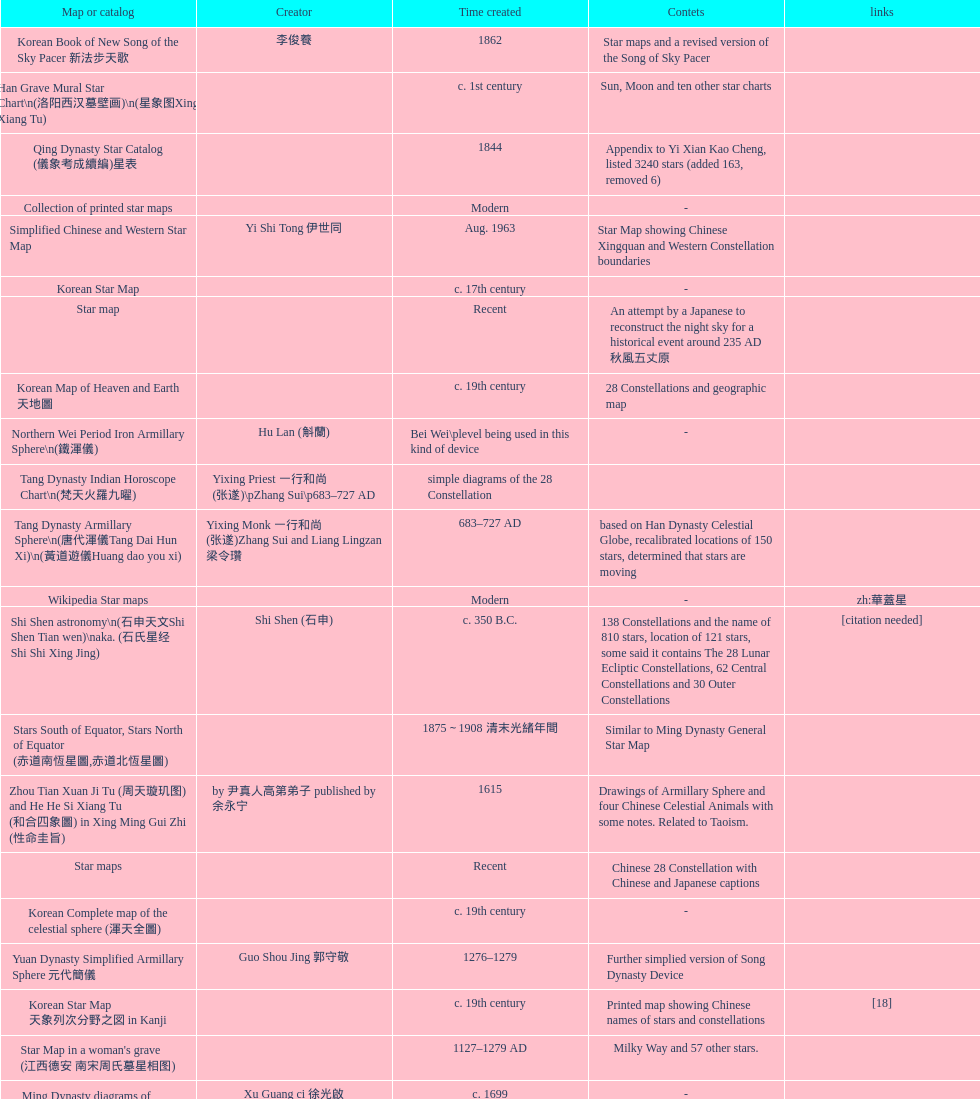Which was the first chinese star map known to have been created? M45 (伏羲星图Fuxixingtu). 